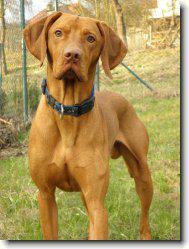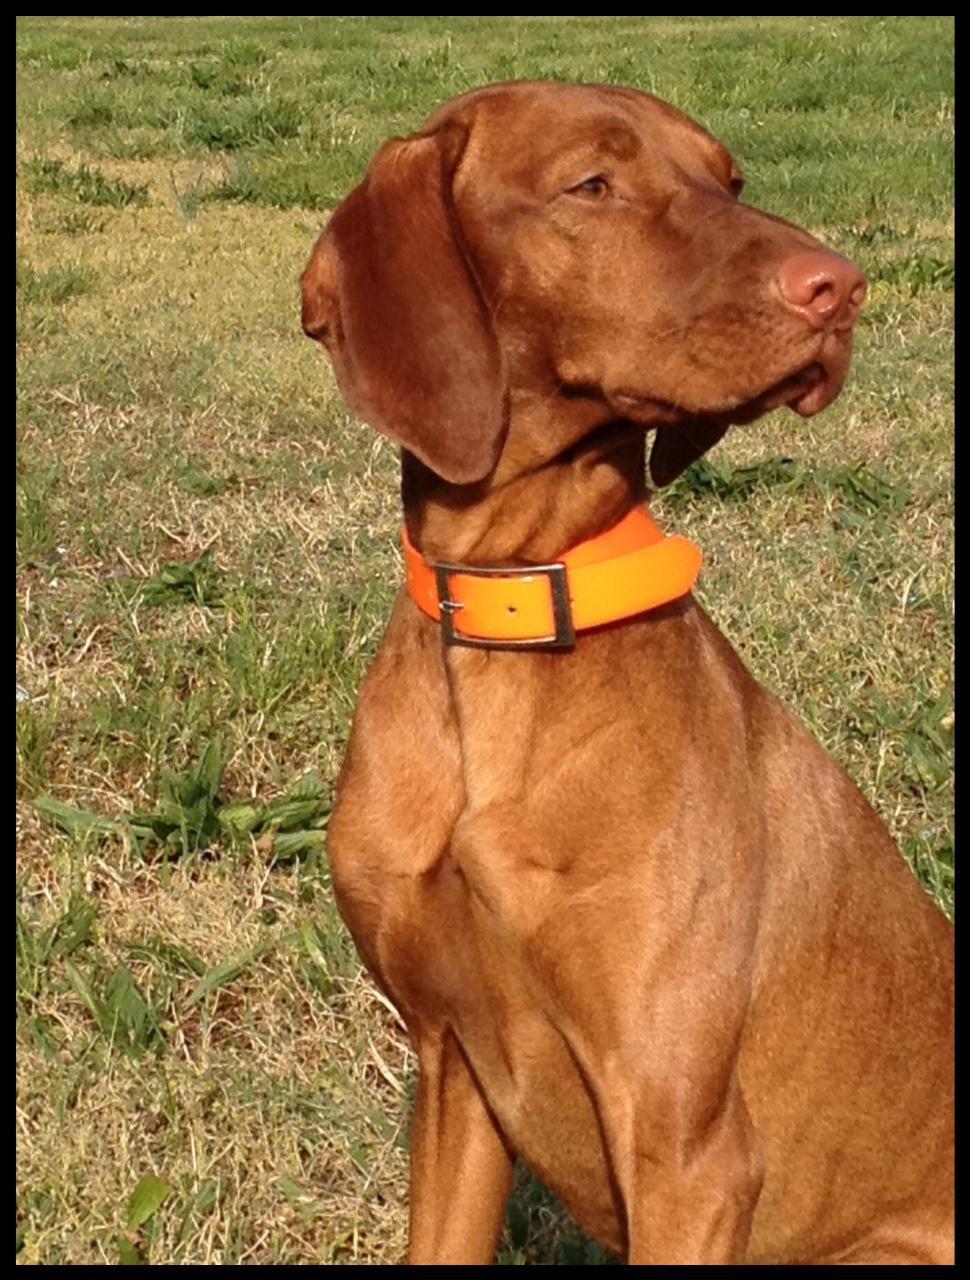The first image is the image on the left, the second image is the image on the right. Considering the images on both sides, is "Each image contains a single dog, and the left image features a dog with its head cocked, while the right image shows a dog looking directly forward with a straight head." valid? Answer yes or no. No. The first image is the image on the left, the second image is the image on the right. Analyze the images presented: Is the assertion "One dog is standing." valid? Answer yes or no. Yes. 